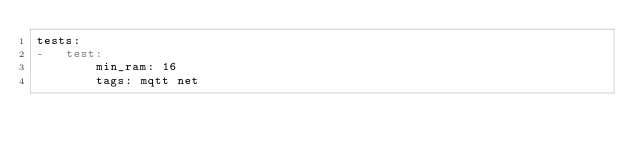Convert code to text. <code><loc_0><loc_0><loc_500><loc_500><_YAML_>tests:
-   test:
        min_ram: 16
        tags: mqtt net
</code> 